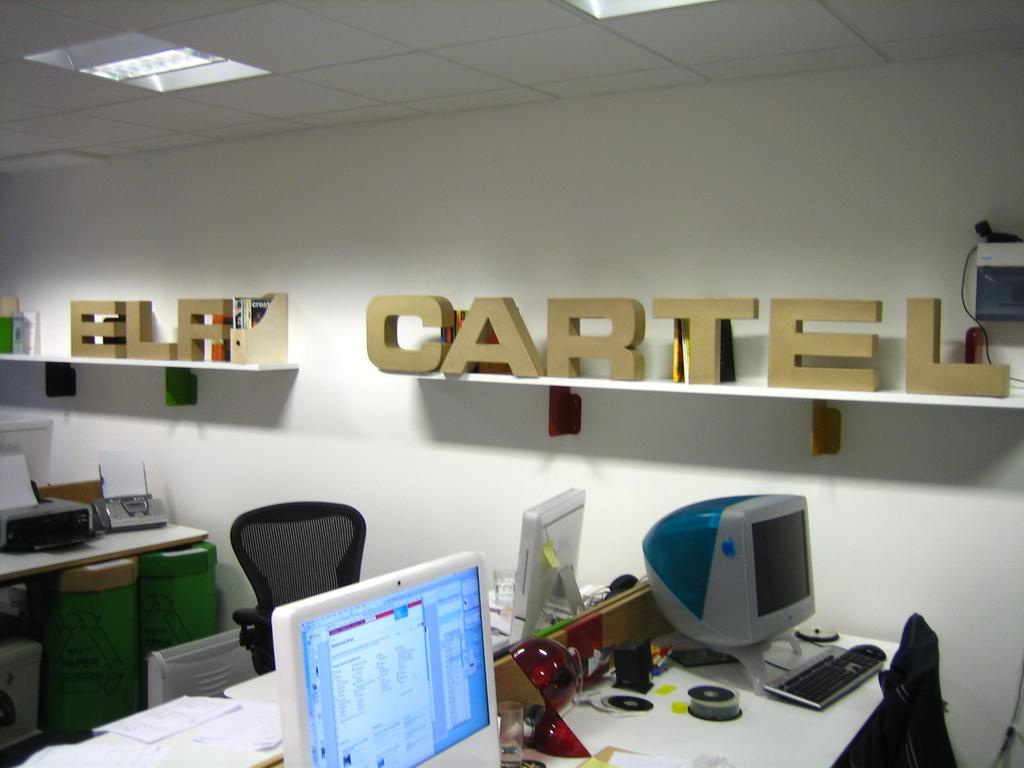<image>
Render a clear and concise summary of the photo. an office that has the word cartel in it 